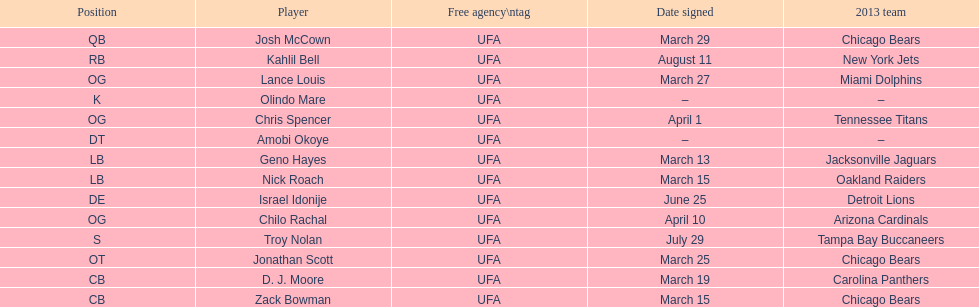Signed the same date as "april fools day". Chris Spencer. 